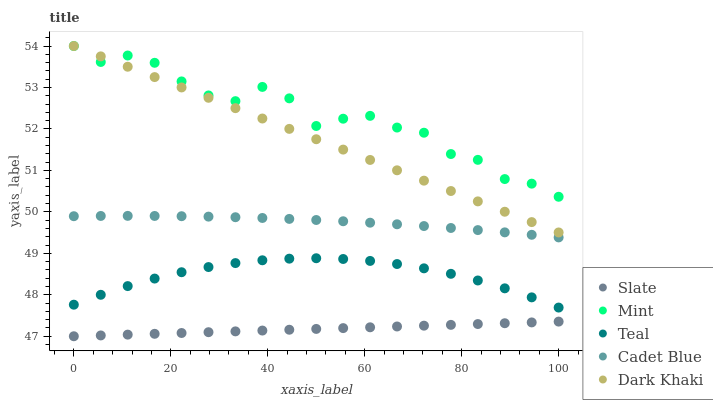Does Slate have the minimum area under the curve?
Answer yes or no. Yes. Does Mint have the maximum area under the curve?
Answer yes or no. Yes. Does Cadet Blue have the minimum area under the curve?
Answer yes or no. No. Does Cadet Blue have the maximum area under the curve?
Answer yes or no. No. Is Dark Khaki the smoothest?
Answer yes or no. Yes. Is Mint the roughest?
Answer yes or no. Yes. Is Slate the smoothest?
Answer yes or no. No. Is Slate the roughest?
Answer yes or no. No. Does Slate have the lowest value?
Answer yes or no. Yes. Does Cadet Blue have the lowest value?
Answer yes or no. No. Does Mint have the highest value?
Answer yes or no. Yes. Does Cadet Blue have the highest value?
Answer yes or no. No. Is Slate less than Mint?
Answer yes or no. Yes. Is Cadet Blue greater than Teal?
Answer yes or no. Yes. Does Dark Khaki intersect Mint?
Answer yes or no. Yes. Is Dark Khaki less than Mint?
Answer yes or no. No. Is Dark Khaki greater than Mint?
Answer yes or no. No. Does Slate intersect Mint?
Answer yes or no. No. 